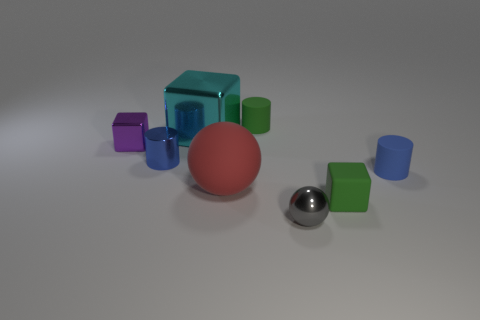Are there fewer small purple objects in front of the big sphere than tiny blue metal cylinders that are on the right side of the tiny green rubber block?
Offer a very short reply. No. There is a tiny object that is in front of the big red ball and behind the metallic ball; what material is it?
Your answer should be very brief. Rubber. There is a big red matte thing; is its shape the same as the tiny metallic object in front of the red thing?
Make the answer very short. Yes. How many other things are the same size as the red sphere?
Your answer should be compact. 1. Is the number of big blue matte balls greater than the number of cylinders?
Offer a terse response. No. How many things are both on the left side of the gray object and in front of the large shiny object?
Offer a very short reply. 3. There is a tiny blue object on the left side of the green thing that is behind the green object in front of the cyan object; what shape is it?
Your answer should be compact. Cylinder. What number of cylinders are either large yellow shiny objects or tiny purple metal objects?
Your response must be concise. 0. There is a tiny cube that is behind the small blue matte cylinder; is it the same color as the shiny sphere?
Offer a terse response. No. What material is the small green object left of the green object in front of the green rubber thing that is to the left of the small gray sphere made of?
Your answer should be compact. Rubber. 